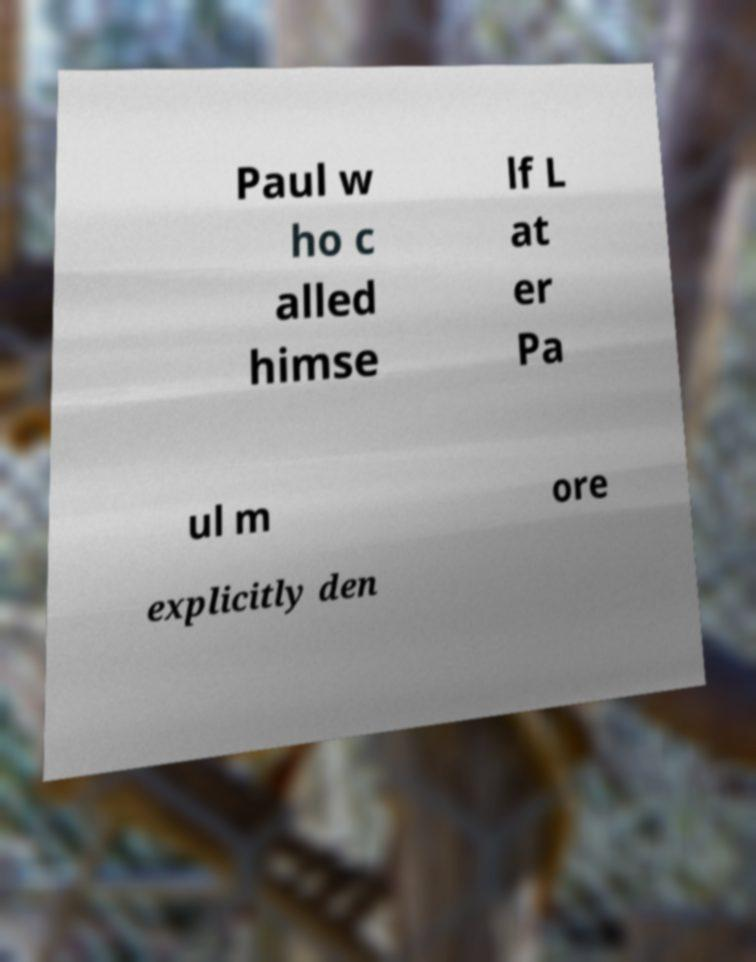Could you assist in decoding the text presented in this image and type it out clearly? Paul w ho c alled himse lf L at er Pa ul m ore explicitly den 